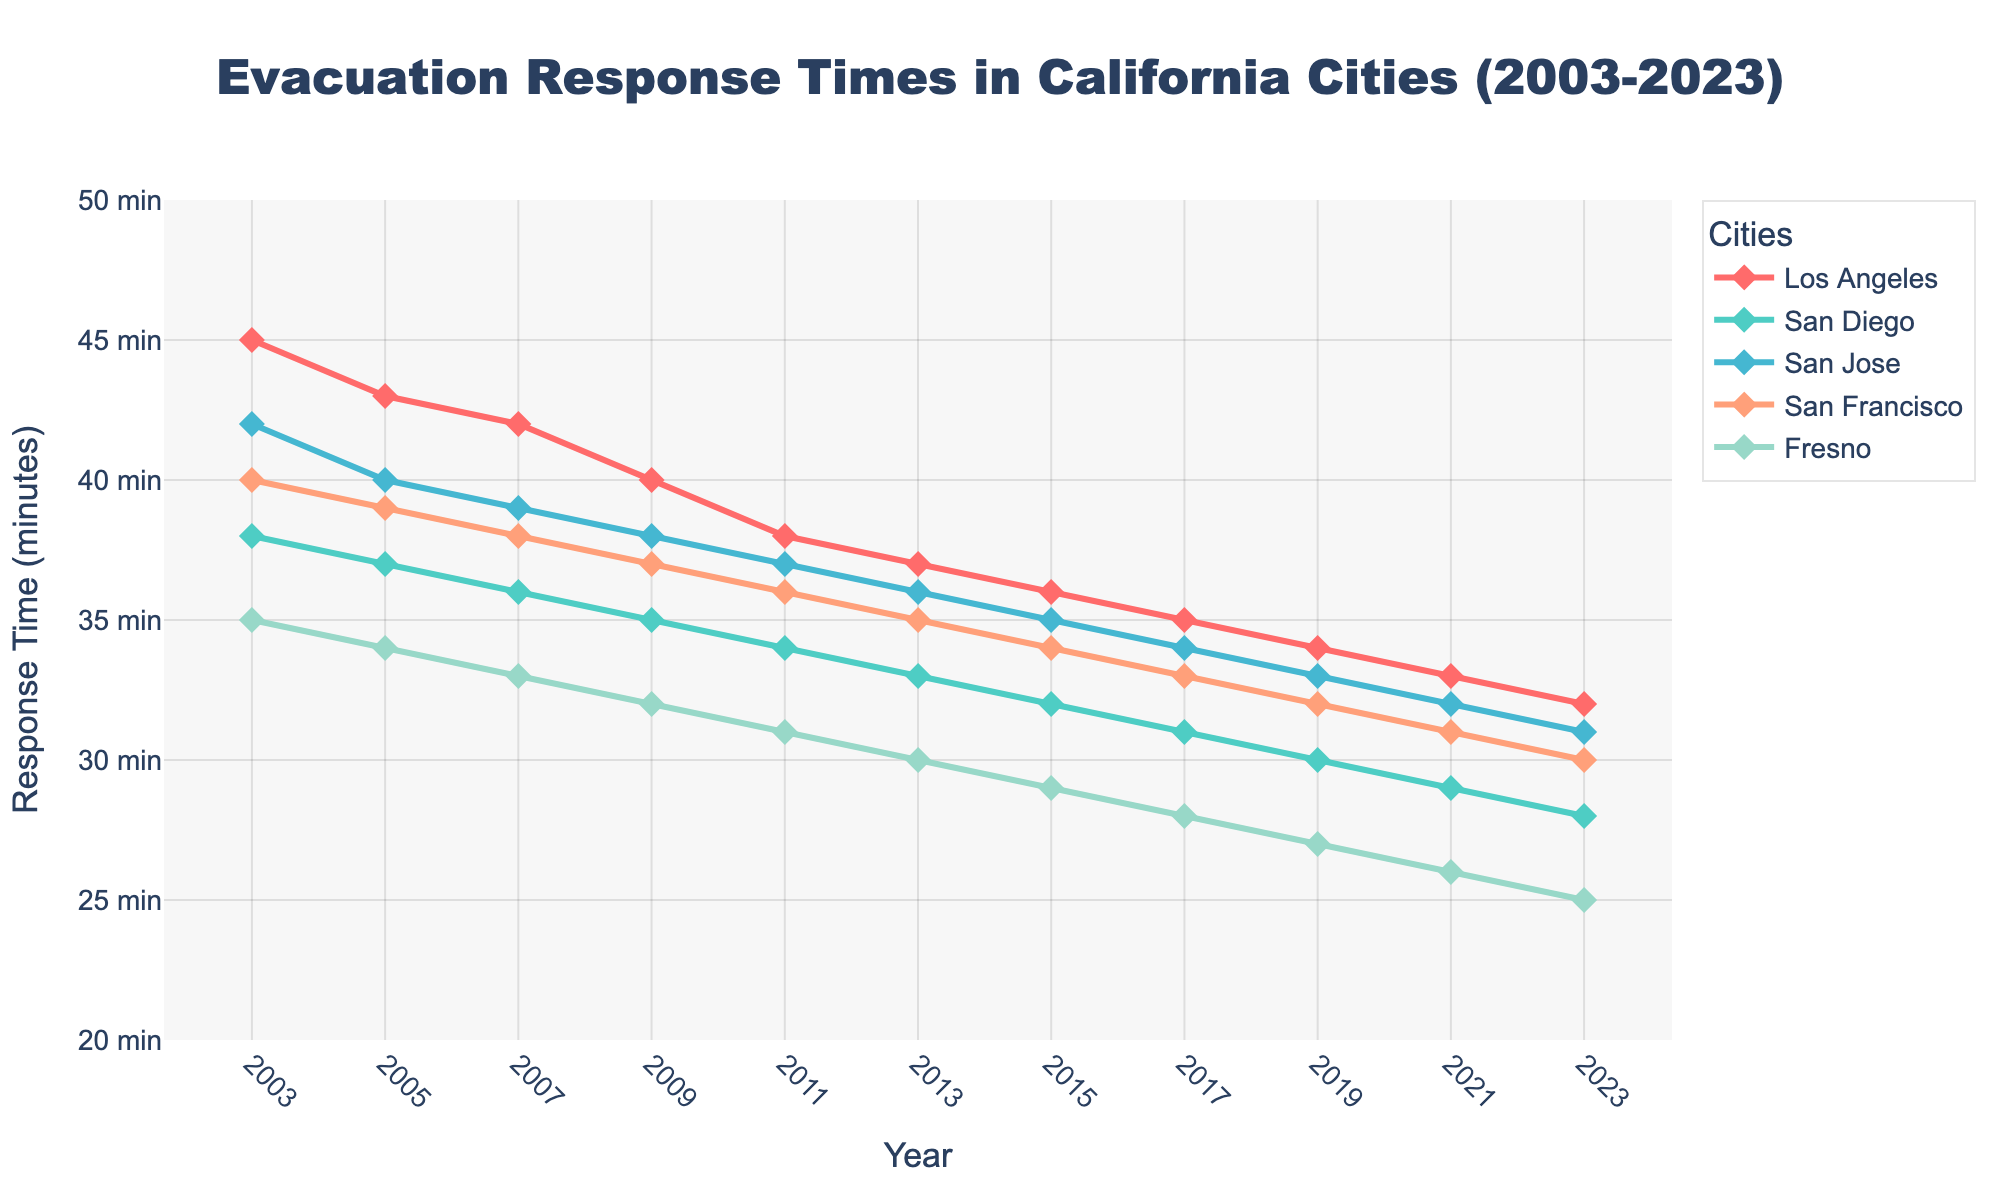What is the average evacuation response time in San Diego across all years? Add up all San Diego response times (38 + 37 + 36 + 35 + 34 + 33 + 32 + 31 + 30 + 29 + 28) = 398. Divide by the number of years (11), so the average is 398 / 11 = 36.18
Answer: 36.18 Which city had the highest evacuation response time in 2003? In 2003, the response times are: Los Angeles (45), San Diego (38), San Jose (42), San Francisco (40), and Fresno (35). The highest response time is in Los Angeles.
Answer: Los Angeles How did the evacuation response time for Los Angeles change from 2003 to 2023? The response time in Los Angeles was 45 minutes in 2003 and decreased to 32 minutes in 2023. The change is 45 - 32 = 13 minutes.
Answer: Decreased by 13 minutes Which city shows the most significant improvement in evacuation response times over the 20 years? Calculate the change for each city: Los Angeles (45 - 32 = 13), San Diego (38 - 28 = 10), San Jose (42 - 31 = 11), San Francisco (40 - 30 = 10), Fresno (35 - 25 = 10). Los Angeles improved the most by 13 minutes.
Answer: Los Angeles In which year does San Francisco have the same response time as San Jose? By examining the data, both San Francisco and San Jose have the same response time of 36 minutes in 2011.
Answer: 2011 What is the range of evacuation response times for Fresno in the data provided? The highest recorded time for Fresno is 35 in 2003, and the lowest is 25 in 2023. The range is 35 - 25 = 10 minutes.
Answer: 10 minutes Which city had the smallest variation in response times across the years? Calculate the difference between the highest and lowest times for each city: Los Angeles (45-32=13), San Diego (38-28=10), San Jose (42-31=11), San Francisco (40-30=10), and Fresno (35-25=10). San Diego, San Francisco, and Fresno each have the smallest variation of 10 minutes.
Answer: San Diego, San Francisco, and Fresno In 2015, which city had the highest evacuation response time, and what was it? For 2015, the response times are: Los Angeles (36), San Diego (32), San Jose (35), San Francisco (34), and Fresno (29). The highest response time is in Los Angeles at 36 minutes.
Answer: Los Angeles, 36 minutes Which city's evacuation response time remained consistently lower than that of Los Angeles throughout the period? Comparing Los Angeles to other cities year by year, all cities (San Diego, San Jose, San Francisco, Fresno) had lower response times in every year.
Answer: All cities (San Diego, San Jose, San Francisco, Fresno) By how many minutes did San Diego's evacuation response time decrease between 2003 and 2023? San Diego’s times were 38 minutes in 2003 and 28 in 2023. The decrease is 38 - 28 = 10 minutes.
Answer: 10 minutes 